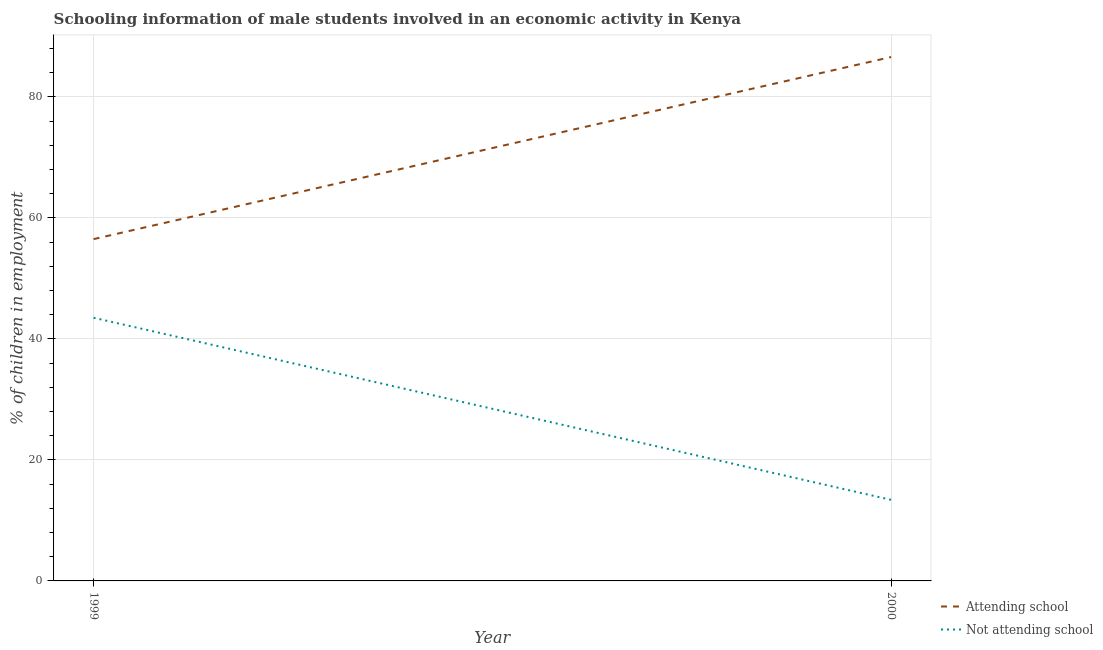How many different coloured lines are there?
Give a very brief answer. 2. Does the line corresponding to percentage of employed males who are not attending school intersect with the line corresponding to percentage of employed males who are attending school?
Provide a short and direct response. No. Is the number of lines equal to the number of legend labels?
Provide a succinct answer. Yes. What is the percentage of employed males who are attending school in 2000?
Make the answer very short. 86.6. Across all years, what is the maximum percentage of employed males who are not attending school?
Your answer should be compact. 43.5. Across all years, what is the minimum percentage of employed males who are attending school?
Provide a succinct answer. 56.5. In which year was the percentage of employed males who are not attending school minimum?
Make the answer very short. 2000. What is the total percentage of employed males who are not attending school in the graph?
Keep it short and to the point. 56.9. What is the difference between the percentage of employed males who are attending school in 1999 and that in 2000?
Provide a succinct answer. -30.1. What is the difference between the percentage of employed males who are attending school in 2000 and the percentage of employed males who are not attending school in 1999?
Provide a short and direct response. 43.1. What is the average percentage of employed males who are not attending school per year?
Provide a short and direct response. 28.45. In the year 2000, what is the difference between the percentage of employed males who are attending school and percentage of employed males who are not attending school?
Offer a terse response. 73.2. In how many years, is the percentage of employed males who are not attending school greater than 32 %?
Provide a short and direct response. 1. What is the ratio of the percentage of employed males who are not attending school in 1999 to that in 2000?
Ensure brevity in your answer.  3.25. Is the percentage of employed males who are not attending school in 1999 less than that in 2000?
Ensure brevity in your answer.  No. Does the percentage of employed males who are not attending school monotonically increase over the years?
Make the answer very short. No. How many lines are there?
Provide a short and direct response. 2. How many years are there in the graph?
Your answer should be very brief. 2. What is the difference between two consecutive major ticks on the Y-axis?
Provide a short and direct response. 20. Where does the legend appear in the graph?
Keep it short and to the point. Bottom right. How many legend labels are there?
Offer a terse response. 2. What is the title of the graph?
Offer a very short reply. Schooling information of male students involved in an economic activity in Kenya. What is the label or title of the Y-axis?
Provide a short and direct response. % of children in employment. What is the % of children in employment of Attending school in 1999?
Provide a short and direct response. 56.5. What is the % of children in employment in Not attending school in 1999?
Make the answer very short. 43.5. What is the % of children in employment of Attending school in 2000?
Your response must be concise. 86.6. What is the % of children in employment in Not attending school in 2000?
Offer a terse response. 13.4. Across all years, what is the maximum % of children in employment of Attending school?
Offer a terse response. 86.6. Across all years, what is the maximum % of children in employment of Not attending school?
Offer a terse response. 43.5. Across all years, what is the minimum % of children in employment in Attending school?
Give a very brief answer. 56.5. Across all years, what is the minimum % of children in employment in Not attending school?
Your response must be concise. 13.4. What is the total % of children in employment of Attending school in the graph?
Your answer should be very brief. 143.1. What is the total % of children in employment in Not attending school in the graph?
Make the answer very short. 56.9. What is the difference between the % of children in employment in Attending school in 1999 and that in 2000?
Keep it short and to the point. -30.1. What is the difference between the % of children in employment of Not attending school in 1999 and that in 2000?
Give a very brief answer. 30.1. What is the difference between the % of children in employment of Attending school in 1999 and the % of children in employment of Not attending school in 2000?
Offer a very short reply. 43.1. What is the average % of children in employment of Attending school per year?
Offer a terse response. 71.55. What is the average % of children in employment in Not attending school per year?
Keep it short and to the point. 28.45. In the year 1999, what is the difference between the % of children in employment in Attending school and % of children in employment in Not attending school?
Your response must be concise. 13. In the year 2000, what is the difference between the % of children in employment in Attending school and % of children in employment in Not attending school?
Make the answer very short. 73.2. What is the ratio of the % of children in employment of Attending school in 1999 to that in 2000?
Give a very brief answer. 0.65. What is the ratio of the % of children in employment of Not attending school in 1999 to that in 2000?
Provide a short and direct response. 3.25. What is the difference between the highest and the second highest % of children in employment of Attending school?
Your answer should be very brief. 30.1. What is the difference between the highest and the second highest % of children in employment of Not attending school?
Offer a terse response. 30.1. What is the difference between the highest and the lowest % of children in employment in Attending school?
Keep it short and to the point. 30.1. What is the difference between the highest and the lowest % of children in employment in Not attending school?
Your answer should be compact. 30.1. 